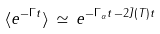Convert formula to latex. <formula><loc_0><loc_0><loc_500><loc_500>\langle e ^ { - \Gamma t } \rangle \, \simeq \, e ^ { - \Gamma _ { \alpha } t \, - 2 \bar { J } ( T ) t }</formula> 